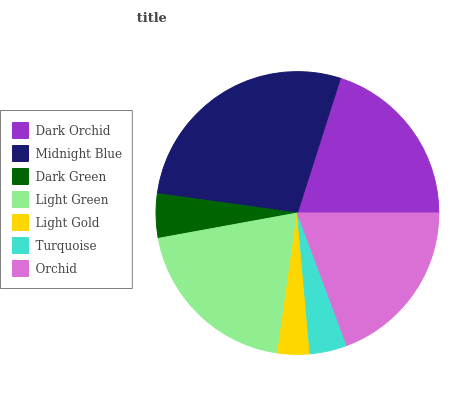Is Light Gold the minimum?
Answer yes or no. Yes. Is Midnight Blue the maximum?
Answer yes or no. Yes. Is Dark Green the minimum?
Answer yes or no. No. Is Dark Green the maximum?
Answer yes or no. No. Is Midnight Blue greater than Dark Green?
Answer yes or no. Yes. Is Dark Green less than Midnight Blue?
Answer yes or no. Yes. Is Dark Green greater than Midnight Blue?
Answer yes or no. No. Is Midnight Blue less than Dark Green?
Answer yes or no. No. Is Orchid the high median?
Answer yes or no. Yes. Is Orchid the low median?
Answer yes or no. Yes. Is Turquoise the high median?
Answer yes or no. No. Is Light Gold the low median?
Answer yes or no. No. 